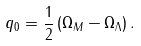<formula> <loc_0><loc_0><loc_500><loc_500>q _ { 0 } = \frac { 1 } { 2 } \left ( \Omega _ { M } - \Omega _ { \Lambda } \right ) .</formula> 